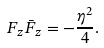<formula> <loc_0><loc_0><loc_500><loc_500>F _ { z } \bar { F } _ { z } = - \frac { \eta ^ { 2 } } 4 .</formula> 